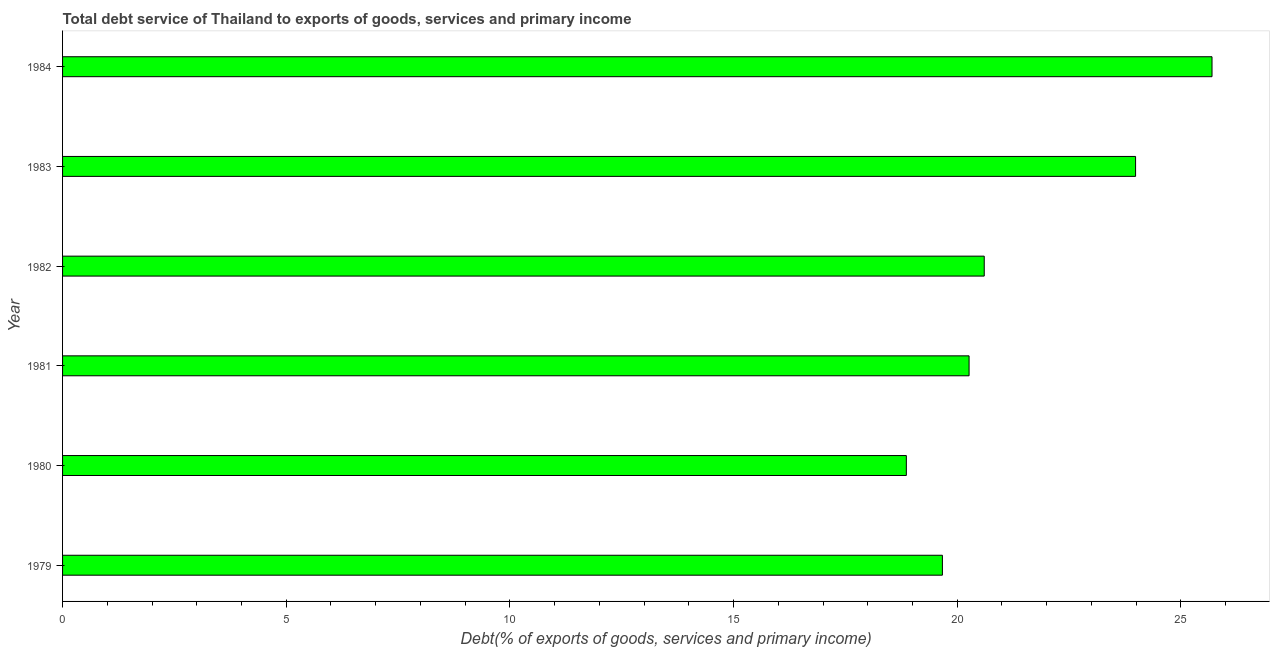Does the graph contain grids?
Ensure brevity in your answer.  No. What is the title of the graph?
Keep it short and to the point. Total debt service of Thailand to exports of goods, services and primary income. What is the label or title of the X-axis?
Your answer should be compact. Debt(% of exports of goods, services and primary income). What is the total debt service in 1979?
Your answer should be very brief. 19.67. Across all years, what is the maximum total debt service?
Provide a succinct answer. 25.7. Across all years, what is the minimum total debt service?
Your answer should be very brief. 18.86. In which year was the total debt service maximum?
Give a very brief answer. 1984. In which year was the total debt service minimum?
Ensure brevity in your answer.  1980. What is the sum of the total debt service?
Your response must be concise. 129.08. What is the difference between the total debt service in 1980 and 1982?
Keep it short and to the point. -1.74. What is the average total debt service per year?
Offer a very short reply. 21.51. What is the median total debt service?
Ensure brevity in your answer.  20.43. In how many years, is the total debt service greater than 9 %?
Keep it short and to the point. 6. Do a majority of the years between 1983 and 1980 (inclusive) have total debt service greater than 20 %?
Your answer should be compact. Yes. What is the ratio of the total debt service in 1979 to that in 1984?
Make the answer very short. 0.77. Is the difference between the total debt service in 1979 and 1981 greater than the difference between any two years?
Keep it short and to the point. No. What is the difference between the highest and the second highest total debt service?
Keep it short and to the point. 1.71. Is the sum of the total debt service in 1979 and 1982 greater than the maximum total debt service across all years?
Keep it short and to the point. Yes. What is the difference between the highest and the lowest total debt service?
Your answer should be compact. 6.83. In how many years, is the total debt service greater than the average total debt service taken over all years?
Ensure brevity in your answer.  2. Are all the bars in the graph horizontal?
Provide a short and direct response. Yes. How many years are there in the graph?
Provide a short and direct response. 6. What is the difference between two consecutive major ticks on the X-axis?
Your response must be concise. 5. Are the values on the major ticks of X-axis written in scientific E-notation?
Keep it short and to the point. No. What is the Debt(% of exports of goods, services and primary income) of 1979?
Your answer should be very brief. 19.67. What is the Debt(% of exports of goods, services and primary income) in 1980?
Keep it short and to the point. 18.86. What is the Debt(% of exports of goods, services and primary income) of 1981?
Keep it short and to the point. 20.26. What is the Debt(% of exports of goods, services and primary income) in 1982?
Your answer should be very brief. 20.6. What is the Debt(% of exports of goods, services and primary income) of 1983?
Give a very brief answer. 23.99. What is the Debt(% of exports of goods, services and primary income) of 1984?
Offer a terse response. 25.7. What is the difference between the Debt(% of exports of goods, services and primary income) in 1979 and 1980?
Give a very brief answer. 0.81. What is the difference between the Debt(% of exports of goods, services and primary income) in 1979 and 1981?
Make the answer very short. -0.6. What is the difference between the Debt(% of exports of goods, services and primary income) in 1979 and 1982?
Provide a short and direct response. -0.94. What is the difference between the Debt(% of exports of goods, services and primary income) in 1979 and 1983?
Offer a terse response. -4.32. What is the difference between the Debt(% of exports of goods, services and primary income) in 1979 and 1984?
Make the answer very short. -6.03. What is the difference between the Debt(% of exports of goods, services and primary income) in 1980 and 1981?
Your answer should be compact. -1.4. What is the difference between the Debt(% of exports of goods, services and primary income) in 1980 and 1982?
Offer a very short reply. -1.74. What is the difference between the Debt(% of exports of goods, services and primary income) in 1980 and 1983?
Offer a very short reply. -5.12. What is the difference between the Debt(% of exports of goods, services and primary income) in 1980 and 1984?
Give a very brief answer. -6.83. What is the difference between the Debt(% of exports of goods, services and primary income) in 1981 and 1982?
Give a very brief answer. -0.34. What is the difference between the Debt(% of exports of goods, services and primary income) in 1981 and 1983?
Make the answer very short. -3.72. What is the difference between the Debt(% of exports of goods, services and primary income) in 1981 and 1984?
Your answer should be compact. -5.43. What is the difference between the Debt(% of exports of goods, services and primary income) in 1982 and 1983?
Your answer should be compact. -3.38. What is the difference between the Debt(% of exports of goods, services and primary income) in 1982 and 1984?
Ensure brevity in your answer.  -5.09. What is the difference between the Debt(% of exports of goods, services and primary income) in 1983 and 1984?
Keep it short and to the point. -1.71. What is the ratio of the Debt(% of exports of goods, services and primary income) in 1979 to that in 1980?
Your answer should be compact. 1.04. What is the ratio of the Debt(% of exports of goods, services and primary income) in 1979 to that in 1981?
Your answer should be very brief. 0.97. What is the ratio of the Debt(% of exports of goods, services and primary income) in 1979 to that in 1982?
Ensure brevity in your answer.  0.95. What is the ratio of the Debt(% of exports of goods, services and primary income) in 1979 to that in 1983?
Give a very brief answer. 0.82. What is the ratio of the Debt(% of exports of goods, services and primary income) in 1979 to that in 1984?
Your answer should be compact. 0.77. What is the ratio of the Debt(% of exports of goods, services and primary income) in 1980 to that in 1982?
Keep it short and to the point. 0.92. What is the ratio of the Debt(% of exports of goods, services and primary income) in 1980 to that in 1983?
Your response must be concise. 0.79. What is the ratio of the Debt(% of exports of goods, services and primary income) in 1980 to that in 1984?
Your response must be concise. 0.73. What is the ratio of the Debt(% of exports of goods, services and primary income) in 1981 to that in 1982?
Ensure brevity in your answer.  0.98. What is the ratio of the Debt(% of exports of goods, services and primary income) in 1981 to that in 1983?
Keep it short and to the point. 0.84. What is the ratio of the Debt(% of exports of goods, services and primary income) in 1981 to that in 1984?
Give a very brief answer. 0.79. What is the ratio of the Debt(% of exports of goods, services and primary income) in 1982 to that in 1983?
Offer a very short reply. 0.86. What is the ratio of the Debt(% of exports of goods, services and primary income) in 1982 to that in 1984?
Your answer should be very brief. 0.8. What is the ratio of the Debt(% of exports of goods, services and primary income) in 1983 to that in 1984?
Your answer should be very brief. 0.93. 